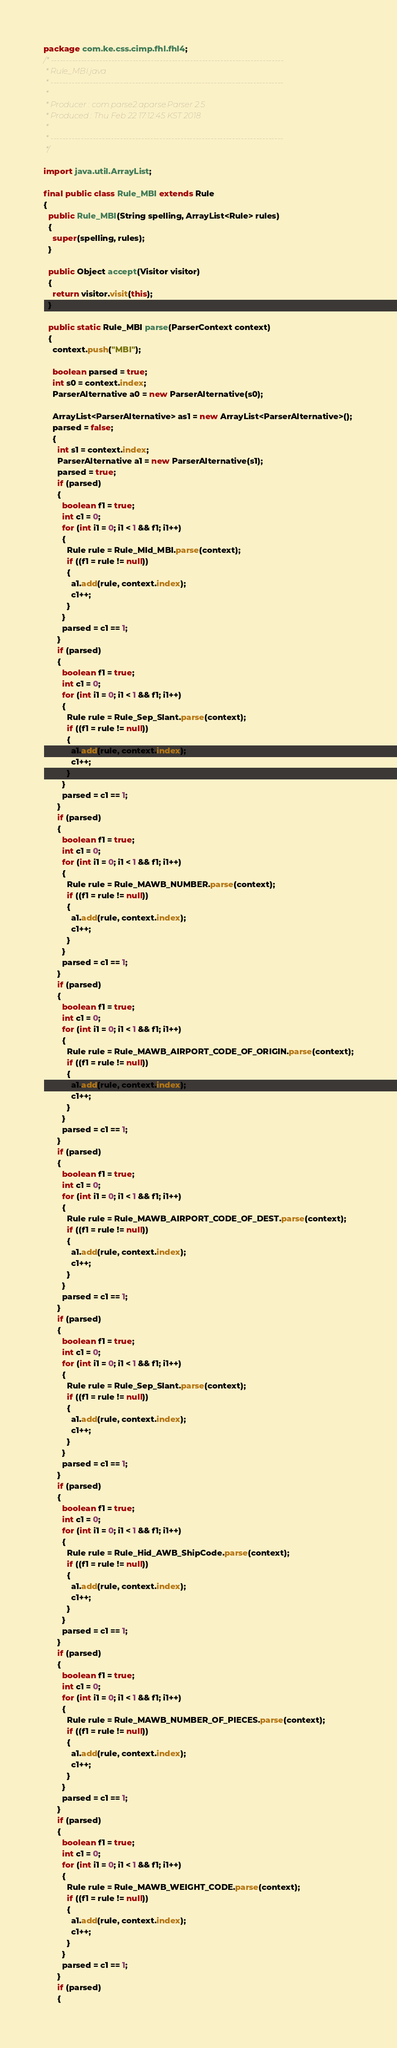<code> <loc_0><loc_0><loc_500><loc_500><_Java_>package com.ke.css.cimp.fhl.fhl4;
/* -----------------------------------------------------------------------------
 * Rule_MBI.java
 * -----------------------------------------------------------------------------
 *
 * Producer : com.parse2.aparse.Parser 2.5
 * Produced : Thu Feb 22 17:12:45 KST 2018
 *
 * -----------------------------------------------------------------------------
 */

import java.util.ArrayList;

final public class Rule_MBI extends Rule
{
  public Rule_MBI(String spelling, ArrayList<Rule> rules)
  {
    super(spelling, rules);
  }

  public Object accept(Visitor visitor)
  {
    return visitor.visit(this);
  }

  public static Rule_MBI parse(ParserContext context)
  {
    context.push("MBI");

    boolean parsed = true;
    int s0 = context.index;
    ParserAlternative a0 = new ParserAlternative(s0);

    ArrayList<ParserAlternative> as1 = new ArrayList<ParserAlternative>();
    parsed = false;
    {
      int s1 = context.index;
      ParserAlternative a1 = new ParserAlternative(s1);
      parsed = true;
      if (parsed)
      {
        boolean f1 = true;
        int c1 = 0;
        for (int i1 = 0; i1 < 1 && f1; i1++)
        {
          Rule rule = Rule_MId_MBI.parse(context);
          if ((f1 = rule != null))
          {
            a1.add(rule, context.index);
            c1++;
          }
        }
        parsed = c1 == 1;
      }
      if (parsed)
      {
        boolean f1 = true;
        int c1 = 0;
        for (int i1 = 0; i1 < 1 && f1; i1++)
        {
          Rule rule = Rule_Sep_Slant.parse(context);
          if ((f1 = rule != null))
          {
            a1.add(rule, context.index);
            c1++;
          }
        }
        parsed = c1 == 1;
      }
      if (parsed)
      {
        boolean f1 = true;
        int c1 = 0;
        for (int i1 = 0; i1 < 1 && f1; i1++)
        {
          Rule rule = Rule_MAWB_NUMBER.parse(context);
          if ((f1 = rule != null))
          {
            a1.add(rule, context.index);
            c1++;
          }
        }
        parsed = c1 == 1;
      }
      if (parsed)
      {
        boolean f1 = true;
        int c1 = 0;
        for (int i1 = 0; i1 < 1 && f1; i1++)
        {
          Rule rule = Rule_MAWB_AIRPORT_CODE_OF_ORIGIN.parse(context);
          if ((f1 = rule != null))
          {
            a1.add(rule, context.index);
            c1++;
          }
        }
        parsed = c1 == 1;
      }
      if (parsed)
      {
        boolean f1 = true;
        int c1 = 0;
        for (int i1 = 0; i1 < 1 && f1; i1++)
        {
          Rule rule = Rule_MAWB_AIRPORT_CODE_OF_DEST.parse(context);
          if ((f1 = rule != null))
          {
            a1.add(rule, context.index);
            c1++;
          }
        }
        parsed = c1 == 1;
      }
      if (parsed)
      {
        boolean f1 = true;
        int c1 = 0;
        for (int i1 = 0; i1 < 1 && f1; i1++)
        {
          Rule rule = Rule_Sep_Slant.parse(context);
          if ((f1 = rule != null))
          {
            a1.add(rule, context.index);
            c1++;
          }
        }
        parsed = c1 == 1;
      }
      if (parsed)
      {
        boolean f1 = true;
        int c1 = 0;
        for (int i1 = 0; i1 < 1 && f1; i1++)
        {
          Rule rule = Rule_Hid_AWB_ShipCode.parse(context);
          if ((f1 = rule != null))
          {
            a1.add(rule, context.index);
            c1++;
          }
        }
        parsed = c1 == 1;
      }
      if (parsed)
      {
        boolean f1 = true;
        int c1 = 0;
        for (int i1 = 0; i1 < 1 && f1; i1++)
        {
          Rule rule = Rule_MAWB_NUMBER_OF_PIECES.parse(context);
          if ((f1 = rule != null))
          {
            a1.add(rule, context.index);
            c1++;
          }
        }
        parsed = c1 == 1;
      }
      if (parsed)
      {
        boolean f1 = true;
        int c1 = 0;
        for (int i1 = 0; i1 < 1 && f1; i1++)
        {
          Rule rule = Rule_MAWB_WEIGHT_CODE.parse(context);
          if ((f1 = rule != null))
          {
            a1.add(rule, context.index);
            c1++;
          }
        }
        parsed = c1 == 1;
      }
      if (parsed)
      {</code> 